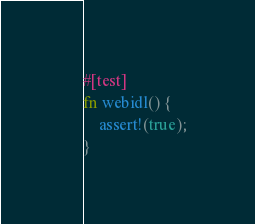<code> <loc_0><loc_0><loc_500><loc_500><_Rust_>#[test]
fn webidl() {
    assert!(true);
}
</code> 